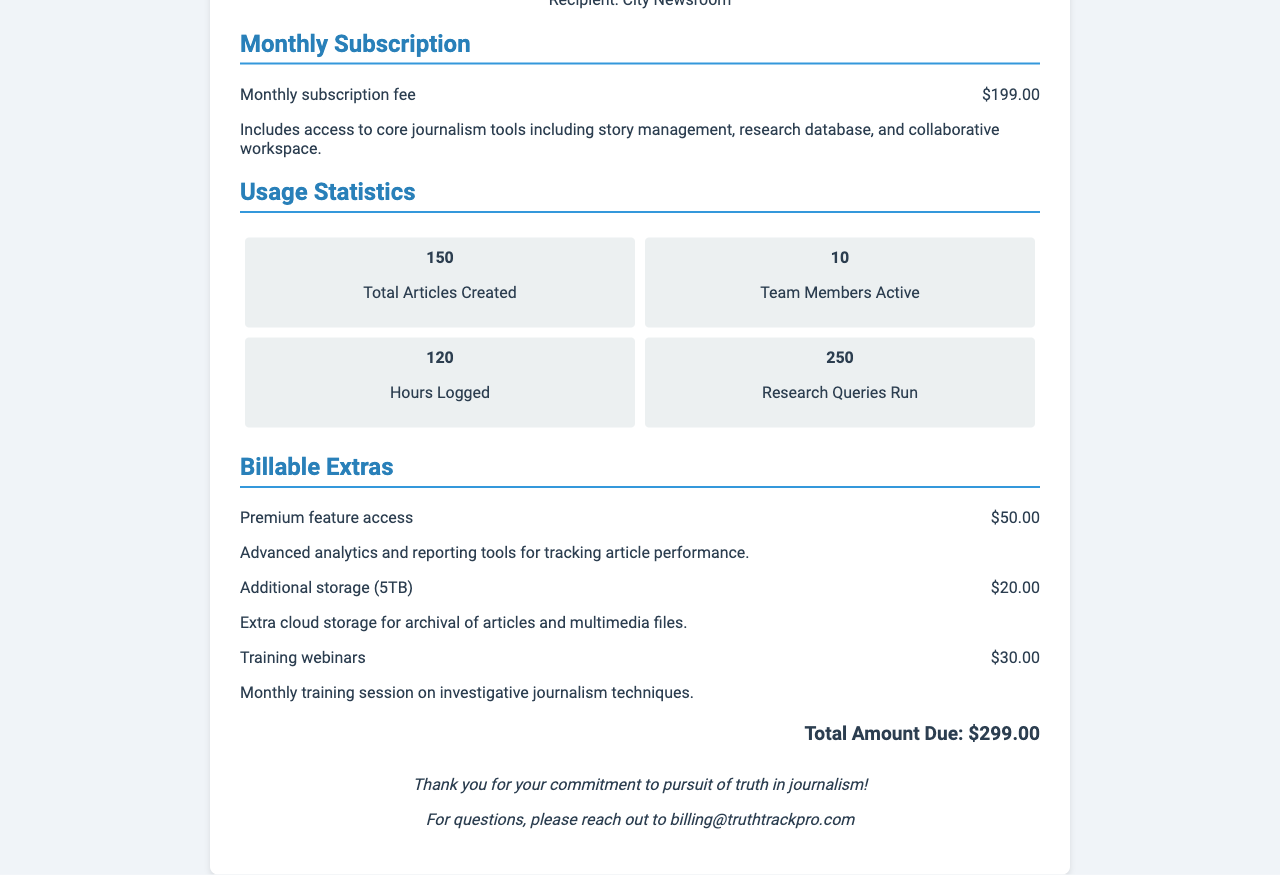What is the monthly subscription fee? The document states that the monthly subscription fee is $199.00.
Answer: $199.00 How many total articles were created? The document mentions that 150 total articles were created.
Answer: 150 What is the total amount due? It states that the total amount due at the end of the document is $299.00.
Answer: $299.00 How many team members were active? The document indicates that 10 team members were active during the billing period.
Answer: 10 What premium feature access charge is listed? The document details that the charge for premium feature access is $50.00.
Answer: $50.00 What date was the receipt issued? According to the document, the receipt was issued on October 1, 2023.
Answer: October 1, 2023 How many hours were logged? The document provides that 120 hours were logged in total.
Answer: 120 What is mentioned about training webinars? The document states that the training webinars cost $30.00.
Answer: $30.00 What is the purpose of the additional storage? The document explains that the additional storage is for archiving articles and multimedia files.
Answer: Archival of articles and multimedia files 